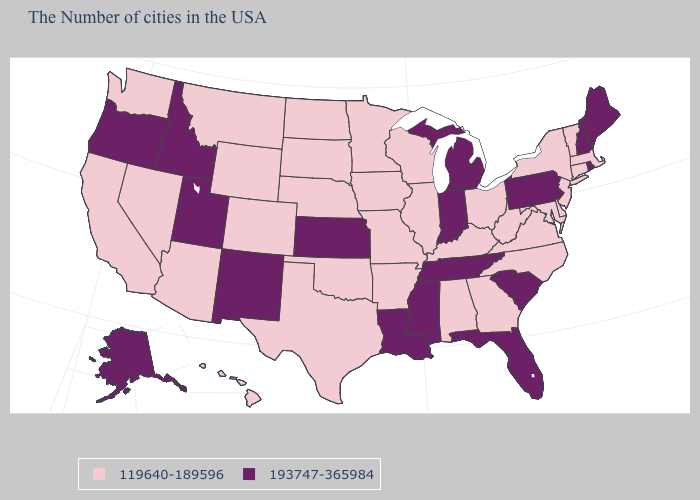Does Michigan have the lowest value in the USA?
Write a very short answer. No. Does South Carolina have the same value as Maine?
Write a very short answer. Yes. Name the states that have a value in the range 119640-189596?
Give a very brief answer. Massachusetts, Vermont, Connecticut, New York, New Jersey, Delaware, Maryland, Virginia, North Carolina, West Virginia, Ohio, Georgia, Kentucky, Alabama, Wisconsin, Illinois, Missouri, Arkansas, Minnesota, Iowa, Nebraska, Oklahoma, Texas, South Dakota, North Dakota, Wyoming, Colorado, Montana, Arizona, Nevada, California, Washington, Hawaii. Among the states that border Virginia , does Tennessee have the lowest value?
Answer briefly. No. Name the states that have a value in the range 119640-189596?
Short answer required. Massachusetts, Vermont, Connecticut, New York, New Jersey, Delaware, Maryland, Virginia, North Carolina, West Virginia, Ohio, Georgia, Kentucky, Alabama, Wisconsin, Illinois, Missouri, Arkansas, Minnesota, Iowa, Nebraska, Oklahoma, Texas, South Dakota, North Dakota, Wyoming, Colorado, Montana, Arizona, Nevada, California, Washington, Hawaii. What is the lowest value in states that border Florida?
Answer briefly. 119640-189596. Name the states that have a value in the range 119640-189596?
Write a very short answer. Massachusetts, Vermont, Connecticut, New York, New Jersey, Delaware, Maryland, Virginia, North Carolina, West Virginia, Ohio, Georgia, Kentucky, Alabama, Wisconsin, Illinois, Missouri, Arkansas, Minnesota, Iowa, Nebraska, Oklahoma, Texas, South Dakota, North Dakota, Wyoming, Colorado, Montana, Arizona, Nevada, California, Washington, Hawaii. What is the value of Arkansas?
Keep it brief. 119640-189596. Does New York have the highest value in the Northeast?
Give a very brief answer. No. What is the value of Louisiana?
Quick response, please. 193747-365984. Name the states that have a value in the range 119640-189596?
Concise answer only. Massachusetts, Vermont, Connecticut, New York, New Jersey, Delaware, Maryland, Virginia, North Carolina, West Virginia, Ohio, Georgia, Kentucky, Alabama, Wisconsin, Illinois, Missouri, Arkansas, Minnesota, Iowa, Nebraska, Oklahoma, Texas, South Dakota, North Dakota, Wyoming, Colorado, Montana, Arizona, Nevada, California, Washington, Hawaii. Does Oklahoma have the same value as Illinois?
Quick response, please. Yes. Among the states that border North Dakota , which have the highest value?
Concise answer only. Minnesota, South Dakota, Montana. Name the states that have a value in the range 119640-189596?
Give a very brief answer. Massachusetts, Vermont, Connecticut, New York, New Jersey, Delaware, Maryland, Virginia, North Carolina, West Virginia, Ohio, Georgia, Kentucky, Alabama, Wisconsin, Illinois, Missouri, Arkansas, Minnesota, Iowa, Nebraska, Oklahoma, Texas, South Dakota, North Dakota, Wyoming, Colorado, Montana, Arizona, Nevada, California, Washington, Hawaii. 